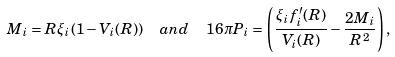<formula> <loc_0><loc_0><loc_500><loc_500>M _ { i } = R \xi _ { i } ( 1 - V _ { i } ( R ) ) \ \ a n d \ \ 1 6 \pi P _ { i } = \left ( \frac { \xi _ { i } f ^ { \prime } _ { i } ( R ) } { V _ { i } ( R ) } - \frac { 2 M _ { i } } { R ^ { 2 } } \right ) ,</formula> 